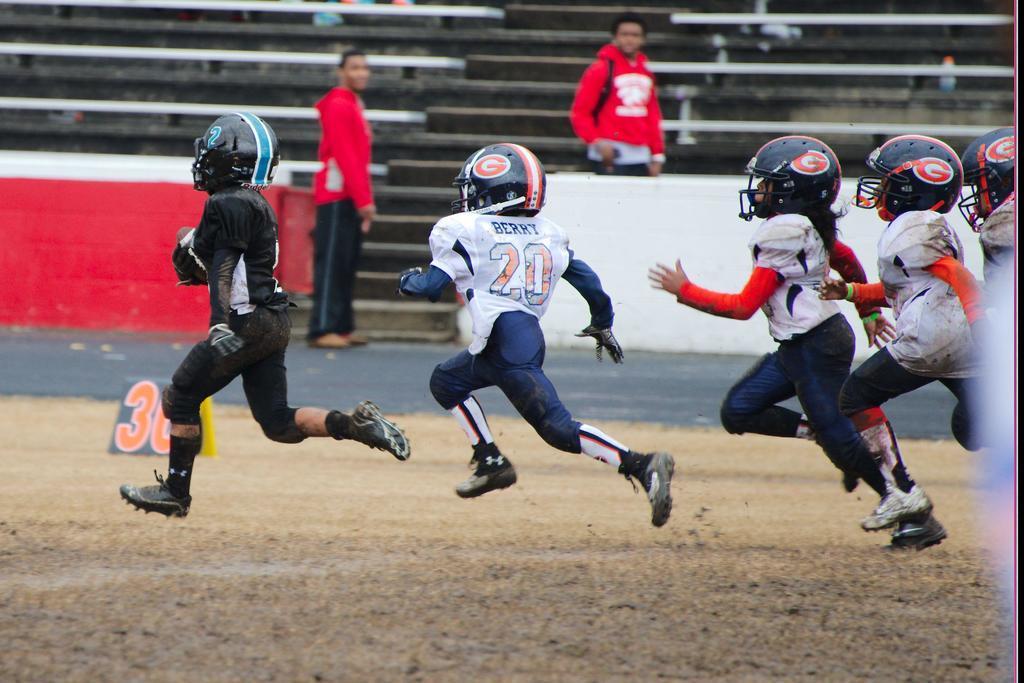How would you summarize this image in a sentence or two? In the center of the image we can see persons running on the ground. In the background we can see stairs, persons and benches. 